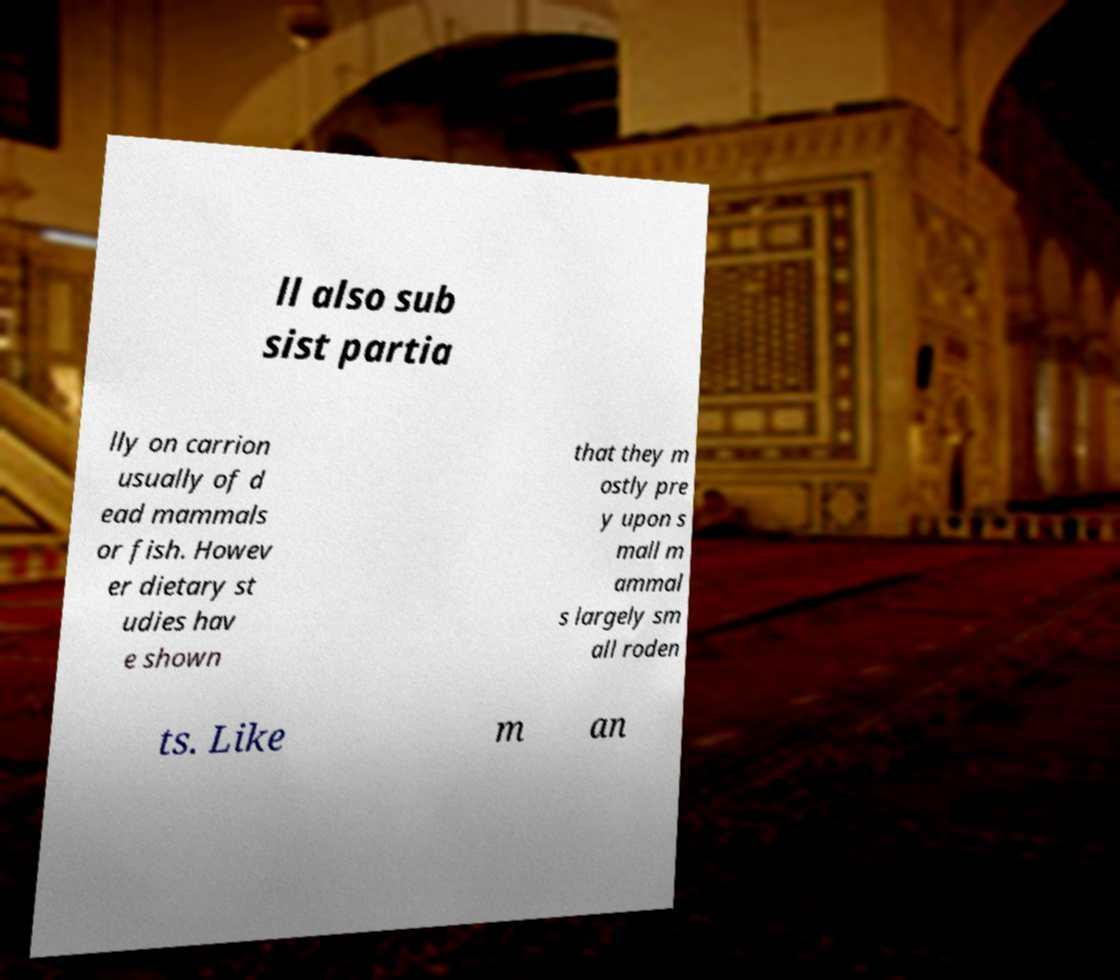Can you accurately transcribe the text from the provided image for me? ll also sub sist partia lly on carrion usually of d ead mammals or fish. Howev er dietary st udies hav e shown that they m ostly pre y upon s mall m ammal s largely sm all roden ts. Like m an 